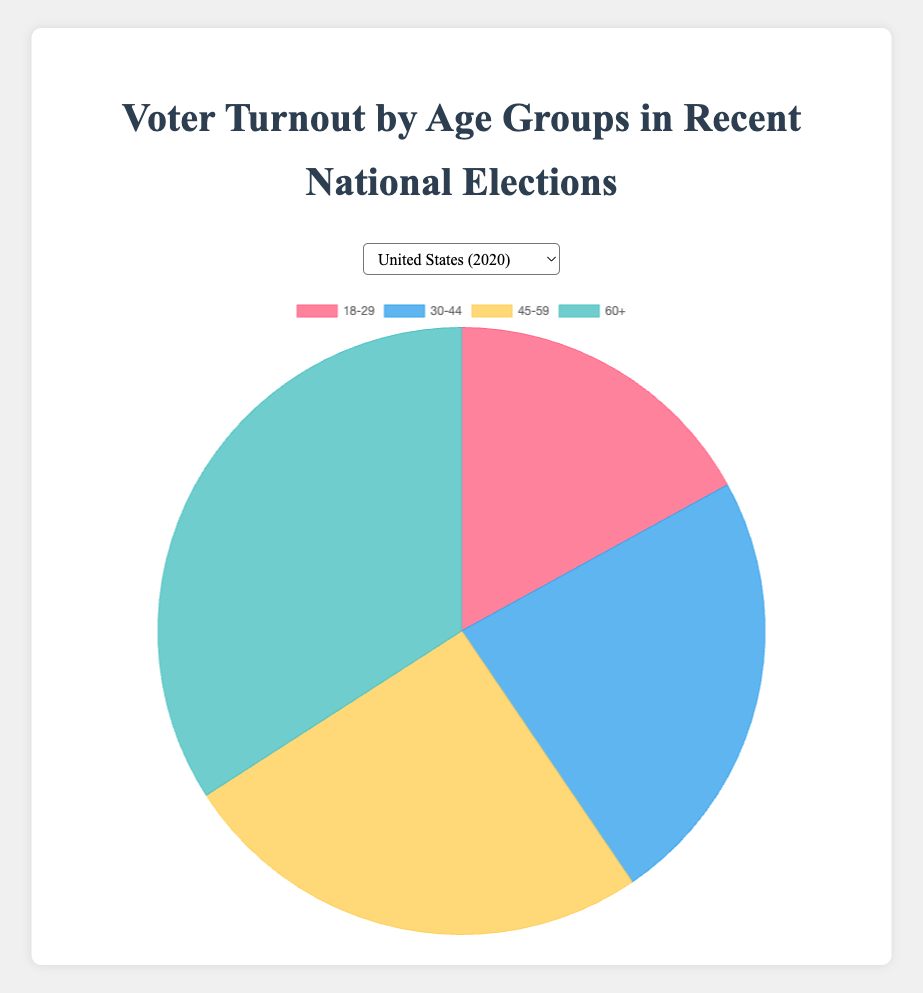Which age group has the highest voter turnout in India? In the pie chart for India, the 30-44 age group has the highest voter turnout percentage compared to other age groups.
Answer: 30-44 Are there any countries where the voter turnout for the 18-29 age group is the highest among all age groups? No, in all the countries shown in the figures, the 18-29 age group does not have the highest voter turnout percentage.
Answer: No For Germany, what is the difference in voter turnout percentage between the 60+ age group and the 18-29 age group? The voter turnout for the 60+ age group is 35.2%, and for the 18-29 age group it is 14.0%. The difference is calculated as 35.2% - 14.0% = 21.2%.
Answer: 21.2% Which country has the most evenly distributed voter turnout across age groups? Among the countries shown, Canada has the most evenly distributed voter turnout percentages across the age groups, with values 20.1%, 24.0%, 26.5%, and 29.4%.
Answer: Canada What is the combined voter turnout percentage for the 45-59 and 60+ age groups in the United States? In the United States, the voter turnout for the 45-59 age group is 25.4%, and for the 60+ age group it is 34.1%. The combined percentage is 25.4% + 34.1% = 59.5%.
Answer: 59.5% In Australia, which age group has the lowest voter turnout percentage and what is that percentage? According to the pie chart for Australia, the 18-29 age group has the lowest voter turnout percentage at 18.7%.
Answer: 18-29, 18.7% Between France and the United Kingdom, which country has a higher voter turnout percentage for the 30-44 age group, and by how much? France has a 22.0% voter turnout for the 30-44 age group, while the United Kingdom has 23.7%. The UK has a higher percentage by 23.7% - 22.0% = 1.7%.
Answer: United Kingdom, 1.7% What is the average voter turnout percentage for the 60+ age group across all the countries? Adding the percentages for the 60+ age group across all countries (34.1 + 35.2 + 33.5 + 29.4 + 28.7 + 21.4 + 29.3) gives a total of 211.6%. Dividing by the number of countries (7), the average is 211.6 / 7 = 30.23%.
Answer: 30.23% 